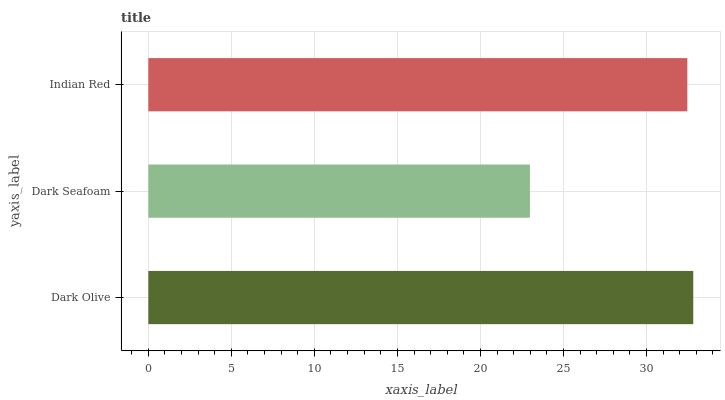Is Dark Seafoam the minimum?
Answer yes or no. Yes. Is Dark Olive the maximum?
Answer yes or no. Yes. Is Indian Red the minimum?
Answer yes or no. No. Is Indian Red the maximum?
Answer yes or no. No. Is Indian Red greater than Dark Seafoam?
Answer yes or no. Yes. Is Dark Seafoam less than Indian Red?
Answer yes or no. Yes. Is Dark Seafoam greater than Indian Red?
Answer yes or no. No. Is Indian Red less than Dark Seafoam?
Answer yes or no. No. Is Indian Red the high median?
Answer yes or no. Yes. Is Indian Red the low median?
Answer yes or no. Yes. Is Dark Seafoam the high median?
Answer yes or no. No. Is Dark Olive the low median?
Answer yes or no. No. 